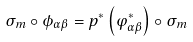Convert formula to latex. <formula><loc_0><loc_0><loc_500><loc_500>\sigma _ { m } \circ \phi _ { \alpha \beta } = p ^ { * } \left ( \varphi _ { \alpha \beta } ^ { * } \right ) \circ \sigma _ { m }</formula> 